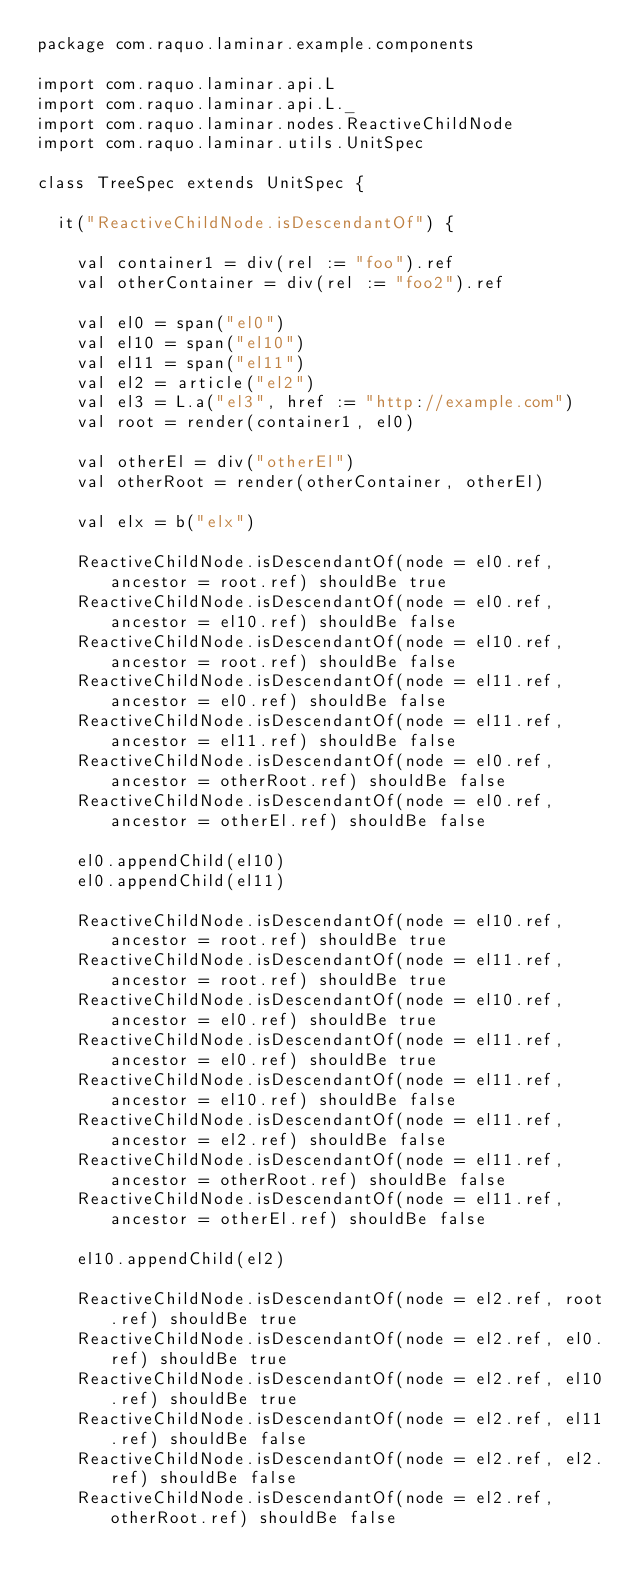Convert code to text. <code><loc_0><loc_0><loc_500><loc_500><_Scala_>package com.raquo.laminar.example.components

import com.raquo.laminar.api.L
import com.raquo.laminar.api.L._
import com.raquo.laminar.nodes.ReactiveChildNode
import com.raquo.laminar.utils.UnitSpec

class TreeSpec extends UnitSpec {

  it("ReactiveChildNode.isDescendantOf") {

    val container1 = div(rel := "foo").ref
    val otherContainer = div(rel := "foo2").ref

    val el0 = span("el0")
    val el10 = span("el10")
    val el11 = span("el11")
    val el2 = article("el2")
    val el3 = L.a("el3", href := "http://example.com")
    val root = render(container1, el0)

    val otherEl = div("otherEl")
    val otherRoot = render(otherContainer, otherEl)

    val elx = b("elx")

    ReactiveChildNode.isDescendantOf(node = el0.ref, ancestor = root.ref) shouldBe true
    ReactiveChildNode.isDescendantOf(node = el0.ref, ancestor = el10.ref) shouldBe false
    ReactiveChildNode.isDescendantOf(node = el10.ref, ancestor = root.ref) shouldBe false
    ReactiveChildNode.isDescendantOf(node = el11.ref, ancestor = el0.ref) shouldBe false
    ReactiveChildNode.isDescendantOf(node = el11.ref, ancestor = el11.ref) shouldBe false
    ReactiveChildNode.isDescendantOf(node = el0.ref, ancestor = otherRoot.ref) shouldBe false
    ReactiveChildNode.isDescendantOf(node = el0.ref, ancestor = otherEl.ref) shouldBe false

    el0.appendChild(el10)
    el0.appendChild(el11)

    ReactiveChildNode.isDescendantOf(node = el10.ref, ancestor = root.ref) shouldBe true
    ReactiveChildNode.isDescendantOf(node = el11.ref, ancestor = root.ref) shouldBe true
    ReactiveChildNode.isDescendantOf(node = el10.ref, ancestor = el0.ref) shouldBe true
    ReactiveChildNode.isDescendantOf(node = el11.ref, ancestor = el0.ref) shouldBe true
    ReactiveChildNode.isDescendantOf(node = el11.ref, ancestor = el10.ref) shouldBe false
    ReactiveChildNode.isDescendantOf(node = el11.ref, ancestor = el2.ref) shouldBe false
    ReactiveChildNode.isDescendantOf(node = el11.ref, ancestor = otherRoot.ref) shouldBe false
    ReactiveChildNode.isDescendantOf(node = el11.ref, ancestor = otherEl.ref) shouldBe false

    el10.appendChild(el2)

    ReactiveChildNode.isDescendantOf(node = el2.ref, root.ref) shouldBe true
    ReactiveChildNode.isDescendantOf(node = el2.ref, el0.ref) shouldBe true
    ReactiveChildNode.isDescendantOf(node = el2.ref, el10.ref) shouldBe true
    ReactiveChildNode.isDescendantOf(node = el2.ref, el11.ref) shouldBe false
    ReactiveChildNode.isDescendantOf(node = el2.ref, el2.ref) shouldBe false
    ReactiveChildNode.isDescendantOf(node = el2.ref, otherRoot.ref) shouldBe false</code> 